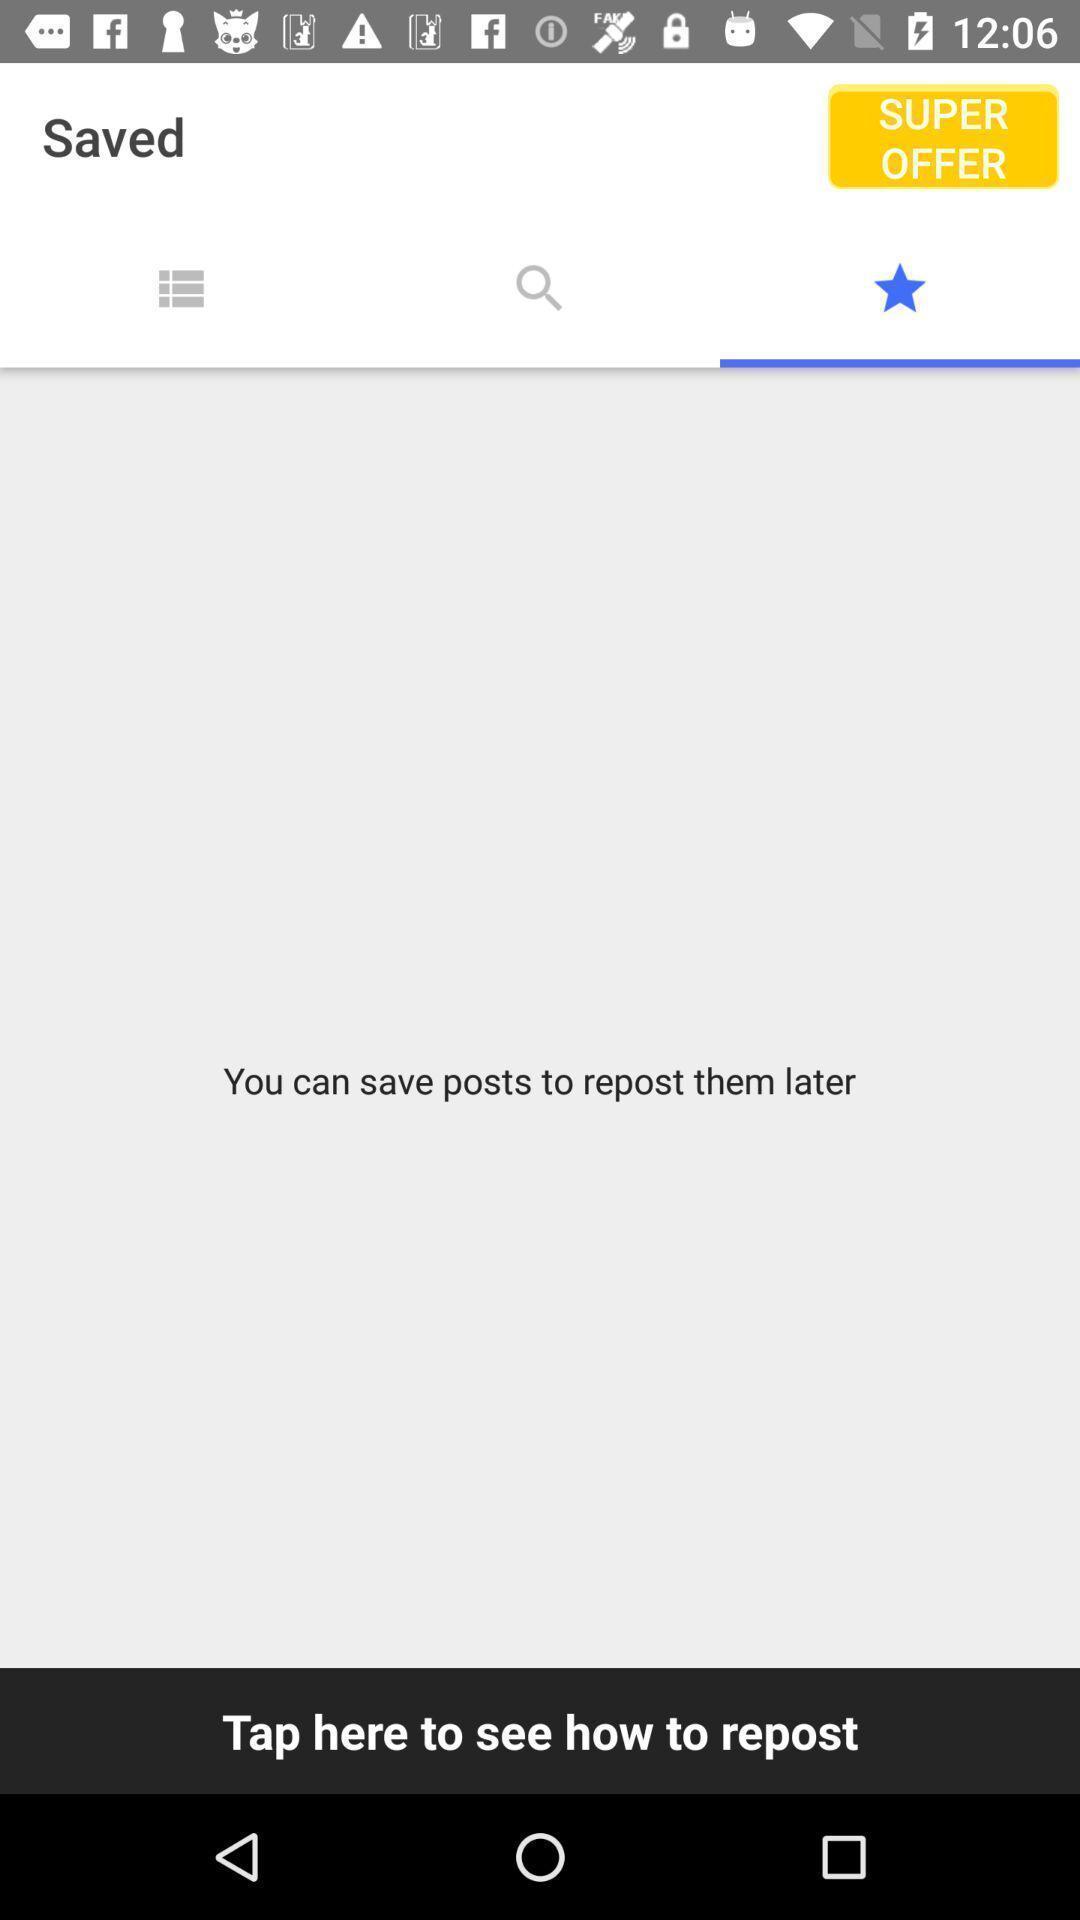Tell me about the visual elements in this screen capture. Page showing the saved posts section in a social app. 